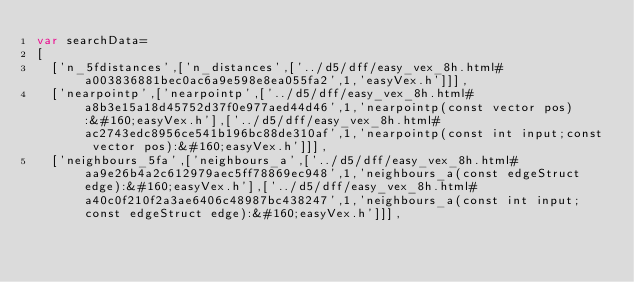Convert code to text. <code><loc_0><loc_0><loc_500><loc_500><_JavaScript_>var searchData=
[
  ['n_5fdistances',['n_distances',['../d5/dff/easy_vex_8h.html#a003836881bec0ac6a9e598e8ea055fa2',1,'easyVex.h']]],
  ['nearpointp',['nearpointp',['../d5/dff/easy_vex_8h.html#a8b3e15a18d45752d37f0e977aed44d46',1,'nearpointp(const vector pos):&#160;easyVex.h'],['../d5/dff/easy_vex_8h.html#ac2743edc8956ce541b196bc88de310af',1,'nearpointp(const int input;const vector pos):&#160;easyVex.h']]],
  ['neighbours_5fa',['neighbours_a',['../d5/dff/easy_vex_8h.html#aa9e26b4a2c612979aec5ff78869ec948',1,'neighbours_a(const edgeStruct edge):&#160;easyVex.h'],['../d5/dff/easy_vex_8h.html#a40c0f210f2a3ae6406c48987bc438247',1,'neighbours_a(const int input;const edgeStruct edge):&#160;easyVex.h']]],</code> 